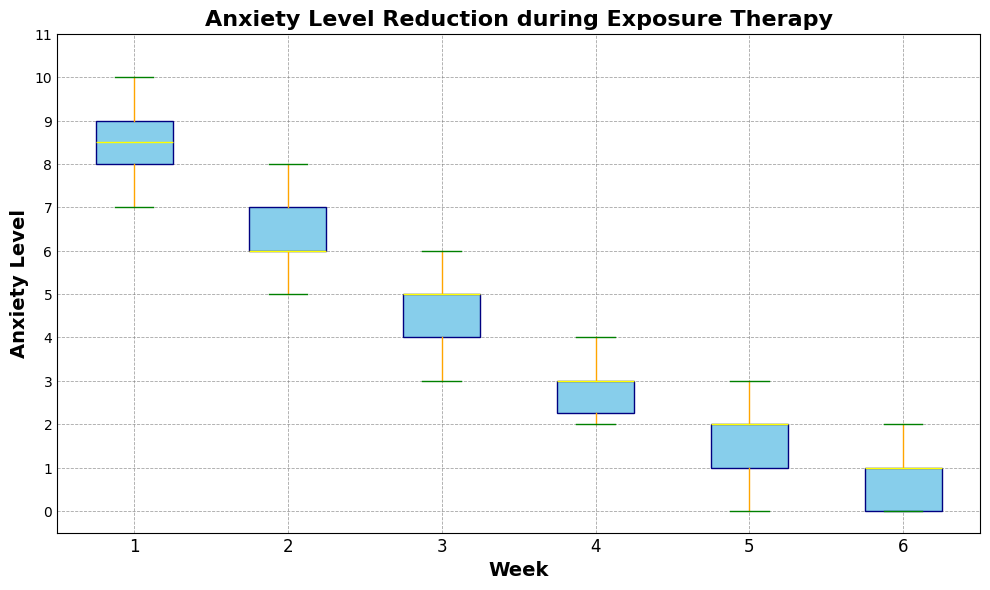How does the median anxiety level change from Week 1 to Week 6? To find the change in median anxiety levels, locate the median line within each week’s box on the plot. The median decreases from Week 1 to Week 6: Week 1 (9), Week 2 (7), Week 3 (5), Week 4 (3), Week 5 (2), and Week 6 (1).
Answer: It decreases gradually What is the interquartile range (IQR) of anxiety levels in Week 3? The IQR is found by subtracting the first quartile (bottom edge of the box) from the third quartile (top edge of the box). For Week 3, the top edge is around 5.5 and the bottom edge is around 4.5, so the IQR is 5.5 - 4.5.
Answer: 1 Which week has the widest range of anxiety levels? The range is determined by the vertical distance between the whiskers. By comparing the whiskers’ lengths, Week 1 has the widest range from 7 (bottom whisker) to 10 (top whisker).
Answer: Week 1 In which week is the anxiety level most spread out? This is identified by looking at the total range (distance between the whiskers) and the IQR (height of the box). Week 1 shows the most spread-out levels with the whiskers extending from 7 to 10 and a wide box.
Answer: Week 1 Which week shows the largest reduction in the median anxiety level compared to the previous week? Comparing the medians for each consecutive week, the largest reduction is from Week 4 (3) to Week 5 (2), which is a drop of 1.
Answer: Week 4 to Week 5 What can you infer about the success of exposure therapy over time based on the plot? Observe the decreasing trend of the medians and overall reduction of spread and outliers as weeks progress. This indicates a consistent reduction in anxiety levels over the course of the therapy.
Answer: Anxiety levels steadily decrease Are there any weeks where the anxiety levels have outliers? Outliers are visually indicated by individual points outside of the whiskers. Weeks 1 and 2 have no clear outliers as there are no points beyond the whiskers.
Answer: No outliers in Weeks 1 and 2 How does the median anxiety level of Week 6 compare to Week 2? Locate the median lines for Weeks 2 and 6. Week 2 has a median of 7, and Week 6 has a median of 1. The median of Week 6 is lower than Week 2.
Answer: Week 6 is lower Which week shows a more consistent reduction in anxiety levels, Week 3 or Week 4? Consistency is shown by a smaller spread within the box and shorter whiskers. Week 4's box and whiskers are shorter than Week 3's, indicating more consistent levels.
Answer: Week 4 